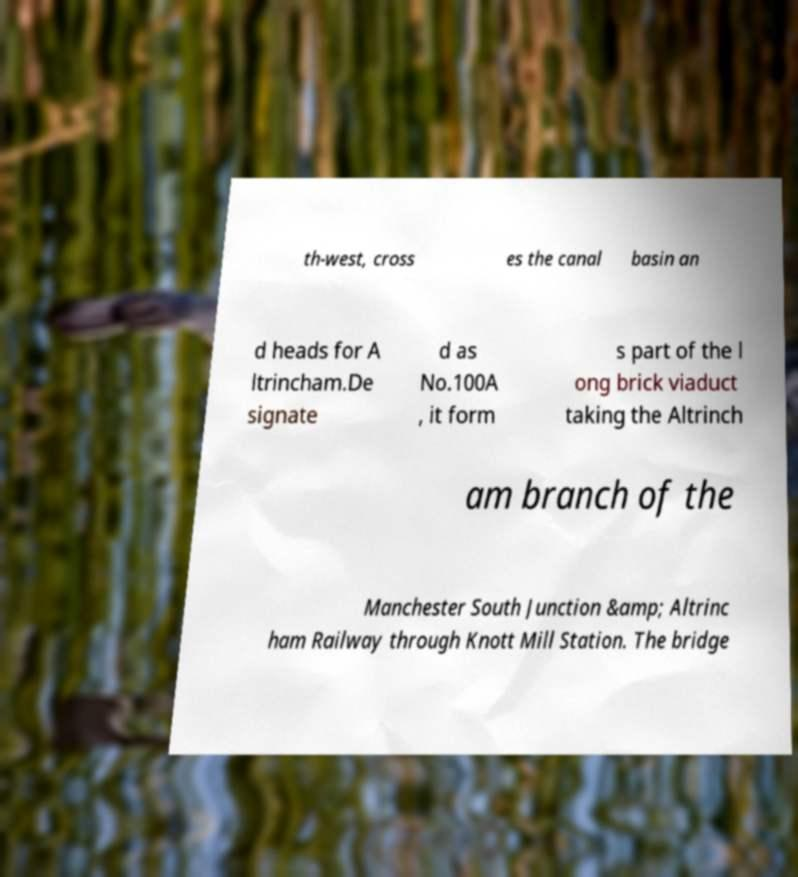What messages or text are displayed in this image? I need them in a readable, typed format. th-west, cross es the canal basin an d heads for A ltrincham.De signate d as No.100A , it form s part of the l ong brick viaduct taking the Altrinch am branch of the Manchester South Junction &amp; Altrinc ham Railway through Knott Mill Station. The bridge 